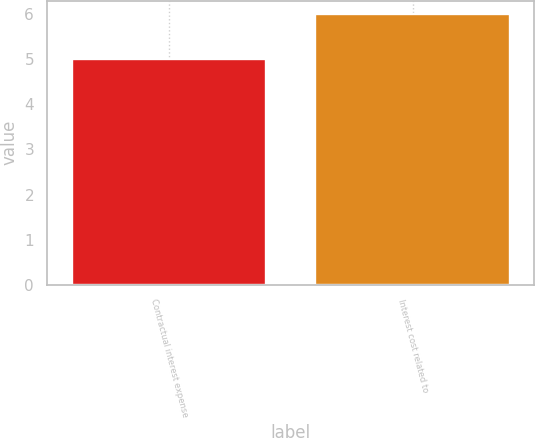Convert chart to OTSL. <chart><loc_0><loc_0><loc_500><loc_500><bar_chart><fcel>Contractual interest expense<fcel>Interest cost related to<nl><fcel>5<fcel>6<nl></chart> 